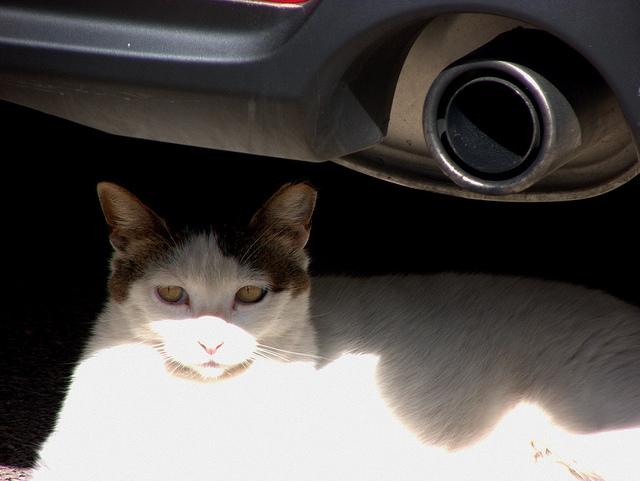What is the cat sitting under?
Short answer required. Car. Are the animal's eyes open or closed?
Short answer required. Open. What is this animal doing?
Give a very brief answer. Resting. Where was this photo taken?
Write a very short answer. Outside. 